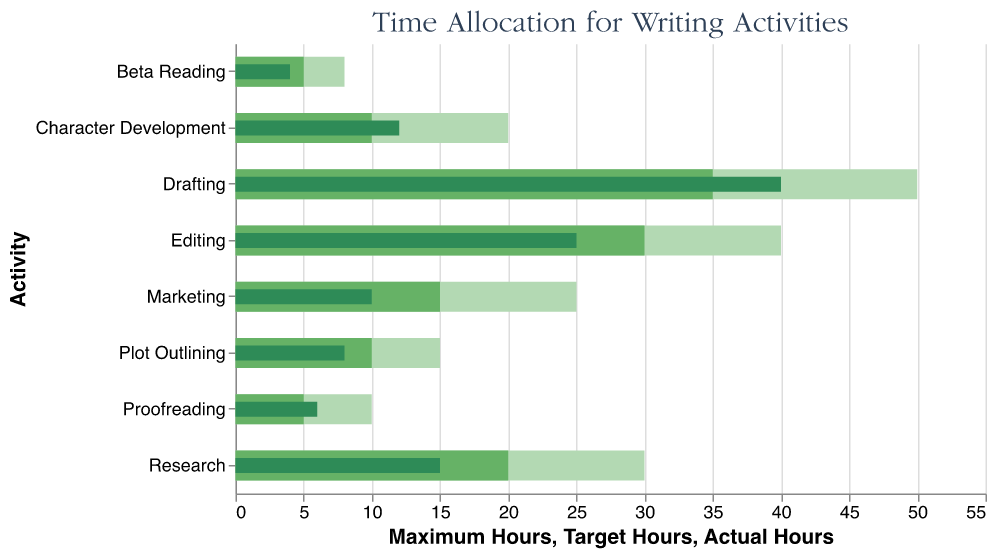what is the title of the chart? The title of the chart is typically located at the top of the figure. For this chart, the title is "Time Allocation for Writing Activities".
Answer: Time Allocation for Writing Activities how many activities are listed in the chart? By counting the number of bars or activity labels on the y-axis, we can see that there are eight activities listed.
Answer: eight which activity has the highest actual hours? By looking at the darkest bar which represents the actual hours, we can see that the "Drafting" activity has the longest bar.
Answer: Drafting is character development over or under the target hours? By examining the length of the dark bar (actual hours) compared to the medium-shaded bar (target hours) for "Character Development", we can see the actual hours exceed the target hours.
Answer: over what is the difference between the target and actual hours for editing? To find the difference, subtract the actual hours from the target hours for the "Editing" activity: 30 (target) - 25 (actual).
Answer: 5 hours which activity has the narrowest range between target and maximum hours? Determine the range for each activity by subtracting target hours from maximum hours and identifying the smallest range. The smallest range is for "Plot Outlining": 15 (maximum) - 10 (target).
Answer: Plot Outlining which activity falls shortest of its target hours? Identify the activity with the smallest dark bar (actual hours) compared to its medium-shaded bar (target hours). "Marketing" falls short by the most significant margin.
Answer: Marketing how many hours in total are targeted for all activities combined? Sum the target hours for all listed activities: 20 (Research) + 35 (Drafting) + 30 (Editing) + 15 (Marketing) + 10 (Character Development) + 10 (Plot Outlining) + 5 (Proofreading) + 5 (Beta Reading) = 130 hours.
Answer: 130 hours which activity has the most significant surplus in actual hours over target hours? Identify the activity where the dark bar (actual hours) exceeds the medium-shaded bar (target hours) by the largest amount. "Drafting" has the most significant surplus of 40 (actual) - 35 (target) = 5 hours.
Answer: Drafting 